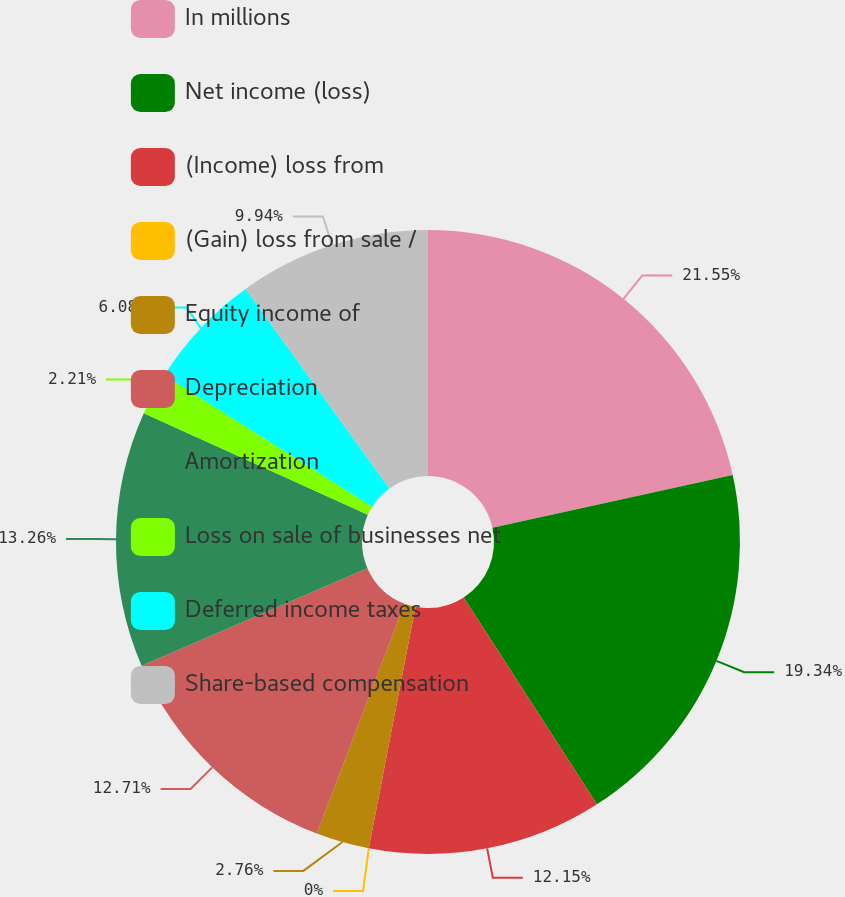Convert chart to OTSL. <chart><loc_0><loc_0><loc_500><loc_500><pie_chart><fcel>In millions<fcel>Net income (loss)<fcel>(Income) loss from<fcel>(Gain) loss from sale /<fcel>Equity income of<fcel>Depreciation<fcel>Amortization<fcel>Loss on sale of businesses net<fcel>Deferred income taxes<fcel>Share-based compensation<nl><fcel>21.55%<fcel>19.34%<fcel>12.15%<fcel>0.0%<fcel>2.76%<fcel>12.71%<fcel>13.26%<fcel>2.21%<fcel>6.08%<fcel>9.94%<nl></chart> 